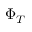Convert formula to latex. <formula><loc_0><loc_0><loc_500><loc_500>\Phi _ { T }</formula> 